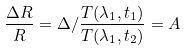<formula> <loc_0><loc_0><loc_500><loc_500>\frac { \Delta R } { R } = \Delta / \frac { T ( \lambda _ { 1 } , t _ { 1 } ) } { T ( \lambda _ { 1 } , t _ { 2 } ) } = A</formula> 